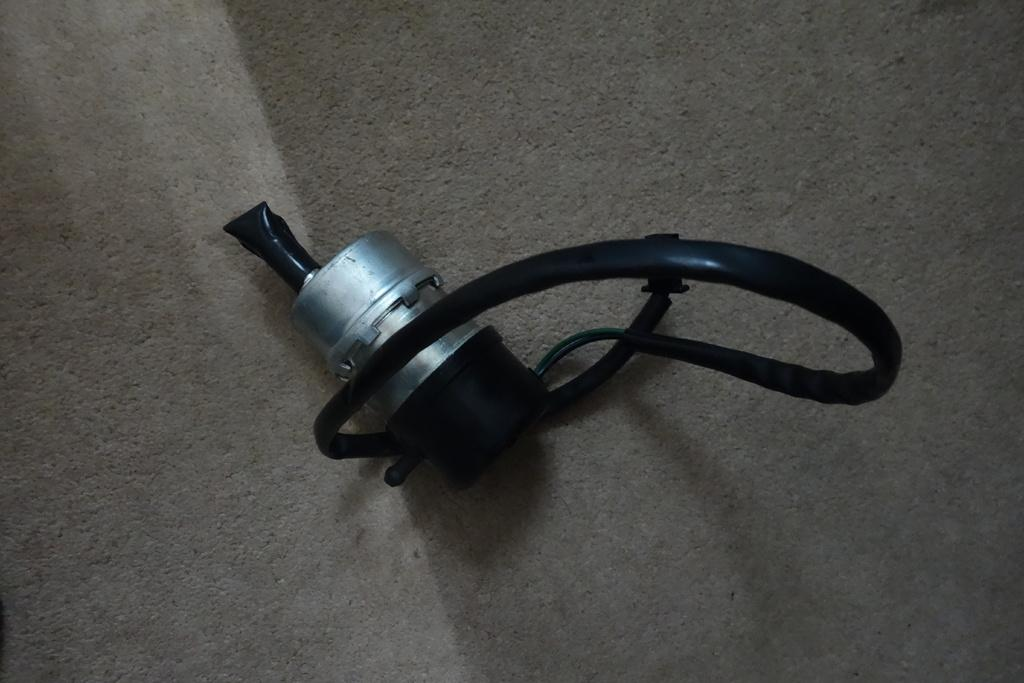What is the main subject of the picture? The main subject of the picture is an exhaust muffler. Can you describe the background of the image? The background of the image is grey in color. How many volleyballs are visible in the image? There are no volleyballs present in the image. What type of disease can be seen affecting the exhaust muffler in the image? There is no disease affecting the exhaust muffler in the image; it appears to be a normal object. 